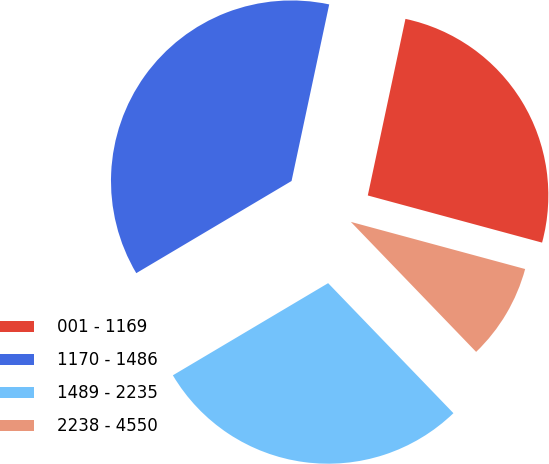Convert chart to OTSL. <chart><loc_0><loc_0><loc_500><loc_500><pie_chart><fcel>001 - 1169<fcel>1170 - 1486<fcel>1489 - 2235<fcel>2238 - 4550<nl><fcel>25.86%<fcel>36.87%<fcel>28.68%<fcel>8.59%<nl></chart> 